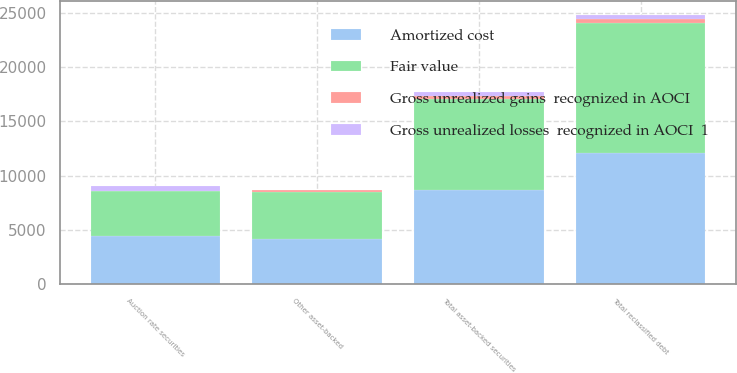<chart> <loc_0><loc_0><loc_500><loc_500><stacked_bar_chart><ecel><fcel>Auction rate securities<fcel>Other asset-backed<fcel>Total asset-backed securities<fcel>Total reclassified debt<nl><fcel>Amortized cost<fcel>4463<fcel>4189<fcel>8652<fcel>12062<nl><fcel>Gross unrealized losses  recognized in AOCI  1<fcel>401<fcel>19<fcel>420<fcel>420<nl><fcel>Gross unrealized gains  recognized in AOCI<fcel>48<fcel>164<fcel>212<fcel>359<nl><fcel>Fair value<fcel>4110<fcel>4334<fcel>8444<fcel>12001<nl></chart> 